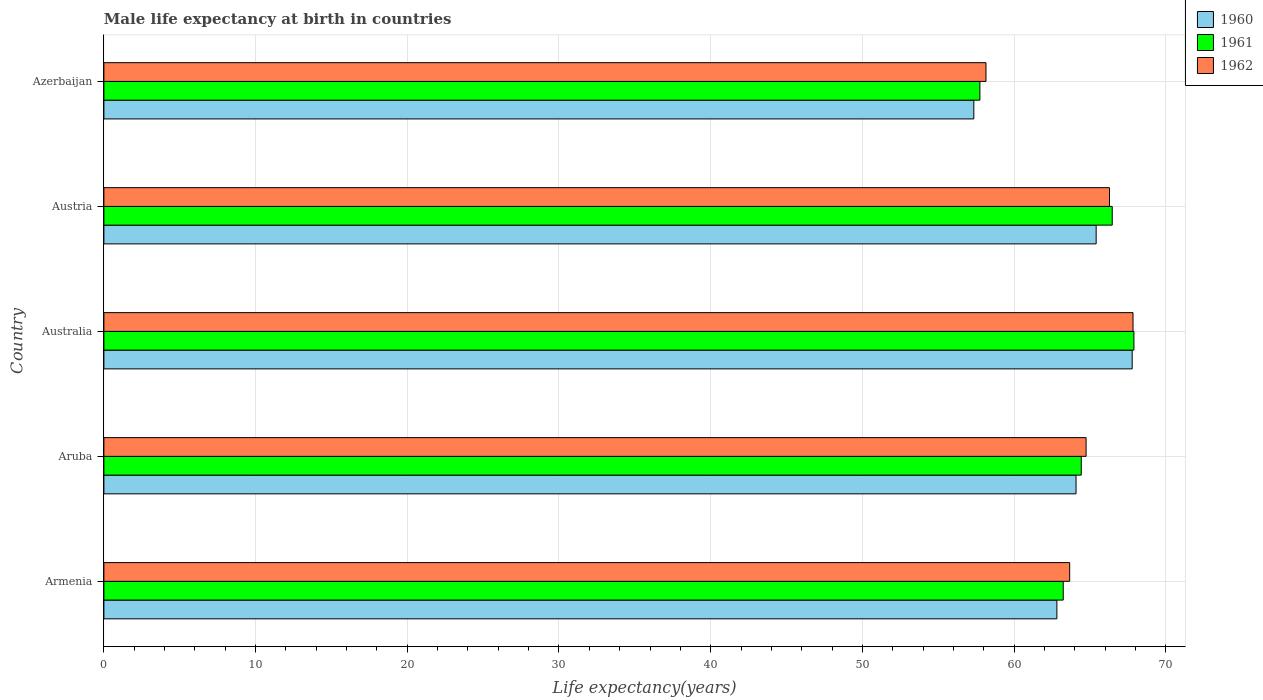How many different coloured bars are there?
Your answer should be very brief. 3. Are the number of bars per tick equal to the number of legend labels?
Provide a short and direct response. Yes. How many bars are there on the 2nd tick from the top?
Give a very brief answer. 3. How many bars are there on the 5th tick from the bottom?
Offer a very short reply. 3. What is the label of the 3rd group of bars from the top?
Your answer should be very brief. Australia. What is the male life expectancy at birth in 1962 in Aruba?
Offer a very short reply. 64.75. Across all countries, what is the maximum male life expectancy at birth in 1962?
Offer a very short reply. 67.84. Across all countries, what is the minimum male life expectancy at birth in 1961?
Your response must be concise. 57.75. In which country was the male life expectancy at birth in 1962 maximum?
Keep it short and to the point. Australia. In which country was the male life expectancy at birth in 1960 minimum?
Provide a short and direct response. Azerbaijan. What is the total male life expectancy at birth in 1961 in the graph?
Offer a terse response. 319.78. What is the difference between the male life expectancy at birth in 1960 in Austria and that in Azerbaijan?
Your answer should be compact. 8.06. What is the difference between the male life expectancy at birth in 1962 in Armenia and the male life expectancy at birth in 1960 in Australia?
Provide a short and direct response. -4.12. What is the average male life expectancy at birth in 1961 per country?
Give a very brief answer. 63.96. What is the difference between the male life expectancy at birth in 1961 and male life expectancy at birth in 1962 in Australia?
Your answer should be very brief. 0.06. What is the ratio of the male life expectancy at birth in 1962 in Armenia to that in Austria?
Make the answer very short. 0.96. Is the difference between the male life expectancy at birth in 1961 in Armenia and Azerbaijan greater than the difference between the male life expectancy at birth in 1962 in Armenia and Azerbaijan?
Your answer should be compact. No. What is the difference between the highest and the second highest male life expectancy at birth in 1961?
Offer a terse response. 1.43. What is the difference between the highest and the lowest male life expectancy at birth in 1960?
Give a very brief answer. 10.44. Is the sum of the male life expectancy at birth in 1961 in Austria and Azerbaijan greater than the maximum male life expectancy at birth in 1962 across all countries?
Make the answer very short. Yes. Is it the case that in every country, the sum of the male life expectancy at birth in 1961 and male life expectancy at birth in 1960 is greater than the male life expectancy at birth in 1962?
Your answer should be very brief. Yes. How many countries are there in the graph?
Offer a very short reply. 5. Are the values on the major ticks of X-axis written in scientific E-notation?
Your response must be concise. No. Does the graph contain any zero values?
Offer a terse response. No. Where does the legend appear in the graph?
Make the answer very short. Top right. How are the legend labels stacked?
Your answer should be compact. Vertical. What is the title of the graph?
Make the answer very short. Male life expectancy at birth in countries. Does "1969" appear as one of the legend labels in the graph?
Offer a very short reply. No. What is the label or title of the X-axis?
Provide a succinct answer. Life expectancy(years). What is the Life expectancy(years) in 1960 in Armenia?
Give a very brief answer. 62.82. What is the Life expectancy(years) of 1961 in Armenia?
Ensure brevity in your answer.  63.24. What is the Life expectancy(years) of 1962 in Armenia?
Make the answer very short. 63.66. What is the Life expectancy(years) of 1960 in Aruba?
Give a very brief answer. 64.08. What is the Life expectancy(years) of 1961 in Aruba?
Offer a very short reply. 64.43. What is the Life expectancy(years) of 1962 in Aruba?
Provide a succinct answer. 64.75. What is the Life expectancy(years) in 1960 in Australia?
Your response must be concise. 67.79. What is the Life expectancy(years) of 1961 in Australia?
Provide a succinct answer. 67.9. What is the Life expectancy(years) of 1962 in Australia?
Make the answer very short. 67.84. What is the Life expectancy(years) of 1960 in Austria?
Offer a terse response. 65.41. What is the Life expectancy(years) of 1961 in Austria?
Offer a very short reply. 66.47. What is the Life expectancy(years) of 1962 in Austria?
Ensure brevity in your answer.  66.29. What is the Life expectancy(years) in 1960 in Azerbaijan?
Your answer should be compact. 57.35. What is the Life expectancy(years) of 1961 in Azerbaijan?
Make the answer very short. 57.75. What is the Life expectancy(years) of 1962 in Azerbaijan?
Offer a very short reply. 58.15. Across all countries, what is the maximum Life expectancy(years) of 1960?
Your answer should be compact. 67.79. Across all countries, what is the maximum Life expectancy(years) of 1961?
Provide a succinct answer. 67.9. Across all countries, what is the maximum Life expectancy(years) of 1962?
Make the answer very short. 67.84. Across all countries, what is the minimum Life expectancy(years) in 1960?
Your answer should be very brief. 57.35. Across all countries, what is the minimum Life expectancy(years) in 1961?
Offer a terse response. 57.75. Across all countries, what is the minimum Life expectancy(years) in 1962?
Your response must be concise. 58.15. What is the total Life expectancy(years) of 1960 in the graph?
Keep it short and to the point. 317.45. What is the total Life expectancy(years) of 1961 in the graph?
Give a very brief answer. 319.79. What is the total Life expectancy(years) in 1962 in the graph?
Provide a succinct answer. 320.69. What is the difference between the Life expectancy(years) of 1960 in Armenia and that in Aruba?
Offer a very short reply. -1.26. What is the difference between the Life expectancy(years) in 1961 in Armenia and that in Aruba?
Your answer should be very brief. -1.19. What is the difference between the Life expectancy(years) in 1962 in Armenia and that in Aruba?
Ensure brevity in your answer.  -1.08. What is the difference between the Life expectancy(years) of 1960 in Armenia and that in Australia?
Provide a short and direct response. -4.96. What is the difference between the Life expectancy(years) in 1961 in Armenia and that in Australia?
Your answer should be very brief. -4.66. What is the difference between the Life expectancy(years) in 1962 in Armenia and that in Australia?
Your response must be concise. -4.18. What is the difference between the Life expectancy(years) of 1960 in Armenia and that in Austria?
Ensure brevity in your answer.  -2.59. What is the difference between the Life expectancy(years) of 1961 in Armenia and that in Austria?
Keep it short and to the point. -3.23. What is the difference between the Life expectancy(years) of 1962 in Armenia and that in Austria?
Make the answer very short. -2.63. What is the difference between the Life expectancy(years) of 1960 in Armenia and that in Azerbaijan?
Your answer should be compact. 5.48. What is the difference between the Life expectancy(years) in 1961 in Armenia and that in Azerbaijan?
Offer a very short reply. 5.49. What is the difference between the Life expectancy(years) of 1962 in Armenia and that in Azerbaijan?
Keep it short and to the point. 5.52. What is the difference between the Life expectancy(years) of 1960 in Aruba and that in Australia?
Provide a succinct answer. -3.7. What is the difference between the Life expectancy(years) of 1961 in Aruba and that in Australia?
Keep it short and to the point. -3.47. What is the difference between the Life expectancy(years) of 1962 in Aruba and that in Australia?
Offer a very short reply. -3.09. What is the difference between the Life expectancy(years) in 1960 in Aruba and that in Austria?
Provide a succinct answer. -1.33. What is the difference between the Life expectancy(years) in 1961 in Aruba and that in Austria?
Offer a terse response. -2.04. What is the difference between the Life expectancy(years) in 1962 in Aruba and that in Austria?
Provide a short and direct response. -1.54. What is the difference between the Life expectancy(years) of 1960 in Aruba and that in Azerbaijan?
Your answer should be compact. 6.74. What is the difference between the Life expectancy(years) of 1961 in Aruba and that in Azerbaijan?
Ensure brevity in your answer.  6.68. What is the difference between the Life expectancy(years) in 1962 in Aruba and that in Azerbaijan?
Offer a terse response. 6.6. What is the difference between the Life expectancy(years) of 1960 in Australia and that in Austria?
Your answer should be very brief. 2.38. What is the difference between the Life expectancy(years) of 1961 in Australia and that in Austria?
Ensure brevity in your answer.  1.43. What is the difference between the Life expectancy(years) of 1962 in Australia and that in Austria?
Provide a succinct answer. 1.55. What is the difference between the Life expectancy(years) of 1960 in Australia and that in Azerbaijan?
Offer a very short reply. 10.44. What is the difference between the Life expectancy(years) in 1961 in Australia and that in Azerbaijan?
Keep it short and to the point. 10.15. What is the difference between the Life expectancy(years) of 1962 in Australia and that in Azerbaijan?
Provide a succinct answer. 9.69. What is the difference between the Life expectancy(years) of 1960 in Austria and that in Azerbaijan?
Your answer should be compact. 8.06. What is the difference between the Life expectancy(years) of 1961 in Austria and that in Azerbaijan?
Offer a terse response. 8.72. What is the difference between the Life expectancy(years) of 1962 in Austria and that in Azerbaijan?
Your response must be concise. 8.14. What is the difference between the Life expectancy(years) in 1960 in Armenia and the Life expectancy(years) in 1961 in Aruba?
Provide a short and direct response. -1.61. What is the difference between the Life expectancy(years) of 1960 in Armenia and the Life expectancy(years) of 1962 in Aruba?
Your answer should be very brief. -1.93. What is the difference between the Life expectancy(years) of 1961 in Armenia and the Life expectancy(years) of 1962 in Aruba?
Keep it short and to the point. -1.51. What is the difference between the Life expectancy(years) of 1960 in Armenia and the Life expectancy(years) of 1961 in Australia?
Give a very brief answer. -5.08. What is the difference between the Life expectancy(years) in 1960 in Armenia and the Life expectancy(years) in 1962 in Australia?
Your answer should be compact. -5.02. What is the difference between the Life expectancy(years) in 1961 in Armenia and the Life expectancy(years) in 1962 in Australia?
Give a very brief answer. -4.6. What is the difference between the Life expectancy(years) of 1960 in Armenia and the Life expectancy(years) of 1961 in Austria?
Give a very brief answer. -3.65. What is the difference between the Life expectancy(years) in 1960 in Armenia and the Life expectancy(years) in 1962 in Austria?
Give a very brief answer. -3.47. What is the difference between the Life expectancy(years) in 1961 in Armenia and the Life expectancy(years) in 1962 in Austria?
Give a very brief answer. -3.05. What is the difference between the Life expectancy(years) in 1960 in Armenia and the Life expectancy(years) in 1961 in Azerbaijan?
Your response must be concise. 5.08. What is the difference between the Life expectancy(years) in 1960 in Armenia and the Life expectancy(years) in 1962 in Azerbaijan?
Make the answer very short. 4.67. What is the difference between the Life expectancy(years) in 1961 in Armenia and the Life expectancy(years) in 1962 in Azerbaijan?
Provide a short and direct response. 5.09. What is the difference between the Life expectancy(years) of 1960 in Aruba and the Life expectancy(years) of 1961 in Australia?
Keep it short and to the point. -3.82. What is the difference between the Life expectancy(years) of 1960 in Aruba and the Life expectancy(years) of 1962 in Australia?
Your answer should be very brief. -3.76. What is the difference between the Life expectancy(years) of 1961 in Aruba and the Life expectancy(years) of 1962 in Australia?
Your answer should be compact. -3.41. What is the difference between the Life expectancy(years) of 1960 in Aruba and the Life expectancy(years) of 1961 in Austria?
Give a very brief answer. -2.39. What is the difference between the Life expectancy(years) in 1960 in Aruba and the Life expectancy(years) in 1962 in Austria?
Your answer should be very brief. -2.21. What is the difference between the Life expectancy(years) of 1961 in Aruba and the Life expectancy(years) of 1962 in Austria?
Your answer should be compact. -1.86. What is the difference between the Life expectancy(years) in 1960 in Aruba and the Life expectancy(years) in 1961 in Azerbaijan?
Your answer should be very brief. 6.34. What is the difference between the Life expectancy(years) in 1960 in Aruba and the Life expectancy(years) in 1962 in Azerbaijan?
Make the answer very short. 5.94. What is the difference between the Life expectancy(years) in 1961 in Aruba and the Life expectancy(years) in 1962 in Azerbaijan?
Make the answer very short. 6.28. What is the difference between the Life expectancy(years) of 1960 in Australia and the Life expectancy(years) of 1961 in Austria?
Give a very brief answer. 1.32. What is the difference between the Life expectancy(years) in 1960 in Australia and the Life expectancy(years) in 1962 in Austria?
Give a very brief answer. 1.5. What is the difference between the Life expectancy(years) in 1961 in Australia and the Life expectancy(years) in 1962 in Austria?
Your response must be concise. 1.61. What is the difference between the Life expectancy(years) of 1960 in Australia and the Life expectancy(years) of 1961 in Azerbaijan?
Keep it short and to the point. 10.04. What is the difference between the Life expectancy(years) in 1960 in Australia and the Life expectancy(years) in 1962 in Azerbaijan?
Keep it short and to the point. 9.64. What is the difference between the Life expectancy(years) of 1961 in Australia and the Life expectancy(years) of 1962 in Azerbaijan?
Offer a terse response. 9.75. What is the difference between the Life expectancy(years) in 1960 in Austria and the Life expectancy(years) in 1961 in Azerbaijan?
Your answer should be very brief. 7.66. What is the difference between the Life expectancy(years) of 1960 in Austria and the Life expectancy(years) of 1962 in Azerbaijan?
Make the answer very short. 7.26. What is the difference between the Life expectancy(years) in 1961 in Austria and the Life expectancy(years) in 1962 in Azerbaijan?
Make the answer very short. 8.32. What is the average Life expectancy(years) in 1960 per country?
Provide a short and direct response. 63.49. What is the average Life expectancy(years) of 1961 per country?
Give a very brief answer. 63.96. What is the average Life expectancy(years) in 1962 per country?
Make the answer very short. 64.14. What is the difference between the Life expectancy(years) in 1960 and Life expectancy(years) in 1961 in Armenia?
Offer a terse response. -0.42. What is the difference between the Life expectancy(years) of 1960 and Life expectancy(years) of 1962 in Armenia?
Ensure brevity in your answer.  -0.84. What is the difference between the Life expectancy(years) of 1961 and Life expectancy(years) of 1962 in Armenia?
Make the answer very short. -0.42. What is the difference between the Life expectancy(years) of 1960 and Life expectancy(years) of 1961 in Aruba?
Provide a short and direct response. -0.34. What is the difference between the Life expectancy(years) of 1960 and Life expectancy(years) of 1962 in Aruba?
Provide a succinct answer. -0.66. What is the difference between the Life expectancy(years) of 1961 and Life expectancy(years) of 1962 in Aruba?
Provide a succinct answer. -0.32. What is the difference between the Life expectancy(years) of 1960 and Life expectancy(years) of 1961 in Australia?
Offer a very short reply. -0.11. What is the difference between the Life expectancy(years) of 1960 and Life expectancy(years) of 1962 in Australia?
Offer a very short reply. -0.05. What is the difference between the Life expectancy(years) in 1960 and Life expectancy(years) in 1961 in Austria?
Your response must be concise. -1.06. What is the difference between the Life expectancy(years) in 1960 and Life expectancy(years) in 1962 in Austria?
Give a very brief answer. -0.88. What is the difference between the Life expectancy(years) in 1961 and Life expectancy(years) in 1962 in Austria?
Ensure brevity in your answer.  0.18. What is the difference between the Life expectancy(years) in 1960 and Life expectancy(years) in 1961 in Azerbaijan?
Give a very brief answer. -0.4. What is the difference between the Life expectancy(years) in 1960 and Life expectancy(years) in 1962 in Azerbaijan?
Keep it short and to the point. -0.8. What is the difference between the Life expectancy(years) of 1961 and Life expectancy(years) of 1962 in Azerbaijan?
Ensure brevity in your answer.  -0.4. What is the ratio of the Life expectancy(years) of 1960 in Armenia to that in Aruba?
Your answer should be compact. 0.98. What is the ratio of the Life expectancy(years) in 1961 in Armenia to that in Aruba?
Your response must be concise. 0.98. What is the ratio of the Life expectancy(years) in 1962 in Armenia to that in Aruba?
Keep it short and to the point. 0.98. What is the ratio of the Life expectancy(years) in 1960 in Armenia to that in Australia?
Provide a short and direct response. 0.93. What is the ratio of the Life expectancy(years) in 1961 in Armenia to that in Australia?
Provide a succinct answer. 0.93. What is the ratio of the Life expectancy(years) in 1962 in Armenia to that in Australia?
Your answer should be compact. 0.94. What is the ratio of the Life expectancy(years) in 1960 in Armenia to that in Austria?
Ensure brevity in your answer.  0.96. What is the ratio of the Life expectancy(years) of 1961 in Armenia to that in Austria?
Ensure brevity in your answer.  0.95. What is the ratio of the Life expectancy(years) in 1962 in Armenia to that in Austria?
Offer a very short reply. 0.96. What is the ratio of the Life expectancy(years) of 1960 in Armenia to that in Azerbaijan?
Your response must be concise. 1.1. What is the ratio of the Life expectancy(years) in 1961 in Armenia to that in Azerbaijan?
Your answer should be very brief. 1.1. What is the ratio of the Life expectancy(years) in 1962 in Armenia to that in Azerbaijan?
Offer a very short reply. 1.09. What is the ratio of the Life expectancy(years) of 1960 in Aruba to that in Australia?
Offer a very short reply. 0.95. What is the ratio of the Life expectancy(years) in 1961 in Aruba to that in Australia?
Offer a terse response. 0.95. What is the ratio of the Life expectancy(years) in 1962 in Aruba to that in Australia?
Keep it short and to the point. 0.95. What is the ratio of the Life expectancy(years) of 1960 in Aruba to that in Austria?
Provide a short and direct response. 0.98. What is the ratio of the Life expectancy(years) of 1961 in Aruba to that in Austria?
Provide a succinct answer. 0.97. What is the ratio of the Life expectancy(years) of 1962 in Aruba to that in Austria?
Keep it short and to the point. 0.98. What is the ratio of the Life expectancy(years) of 1960 in Aruba to that in Azerbaijan?
Make the answer very short. 1.12. What is the ratio of the Life expectancy(years) of 1961 in Aruba to that in Azerbaijan?
Keep it short and to the point. 1.12. What is the ratio of the Life expectancy(years) of 1962 in Aruba to that in Azerbaijan?
Give a very brief answer. 1.11. What is the ratio of the Life expectancy(years) of 1960 in Australia to that in Austria?
Offer a terse response. 1.04. What is the ratio of the Life expectancy(years) in 1961 in Australia to that in Austria?
Your answer should be compact. 1.02. What is the ratio of the Life expectancy(years) of 1962 in Australia to that in Austria?
Give a very brief answer. 1.02. What is the ratio of the Life expectancy(years) of 1960 in Australia to that in Azerbaijan?
Provide a short and direct response. 1.18. What is the ratio of the Life expectancy(years) in 1961 in Australia to that in Azerbaijan?
Provide a succinct answer. 1.18. What is the ratio of the Life expectancy(years) of 1960 in Austria to that in Azerbaijan?
Provide a short and direct response. 1.14. What is the ratio of the Life expectancy(years) of 1961 in Austria to that in Azerbaijan?
Give a very brief answer. 1.15. What is the ratio of the Life expectancy(years) of 1962 in Austria to that in Azerbaijan?
Provide a short and direct response. 1.14. What is the difference between the highest and the second highest Life expectancy(years) in 1960?
Ensure brevity in your answer.  2.38. What is the difference between the highest and the second highest Life expectancy(years) of 1961?
Ensure brevity in your answer.  1.43. What is the difference between the highest and the second highest Life expectancy(years) in 1962?
Provide a succinct answer. 1.55. What is the difference between the highest and the lowest Life expectancy(years) of 1960?
Ensure brevity in your answer.  10.44. What is the difference between the highest and the lowest Life expectancy(years) in 1961?
Offer a very short reply. 10.15. What is the difference between the highest and the lowest Life expectancy(years) of 1962?
Your answer should be compact. 9.69. 